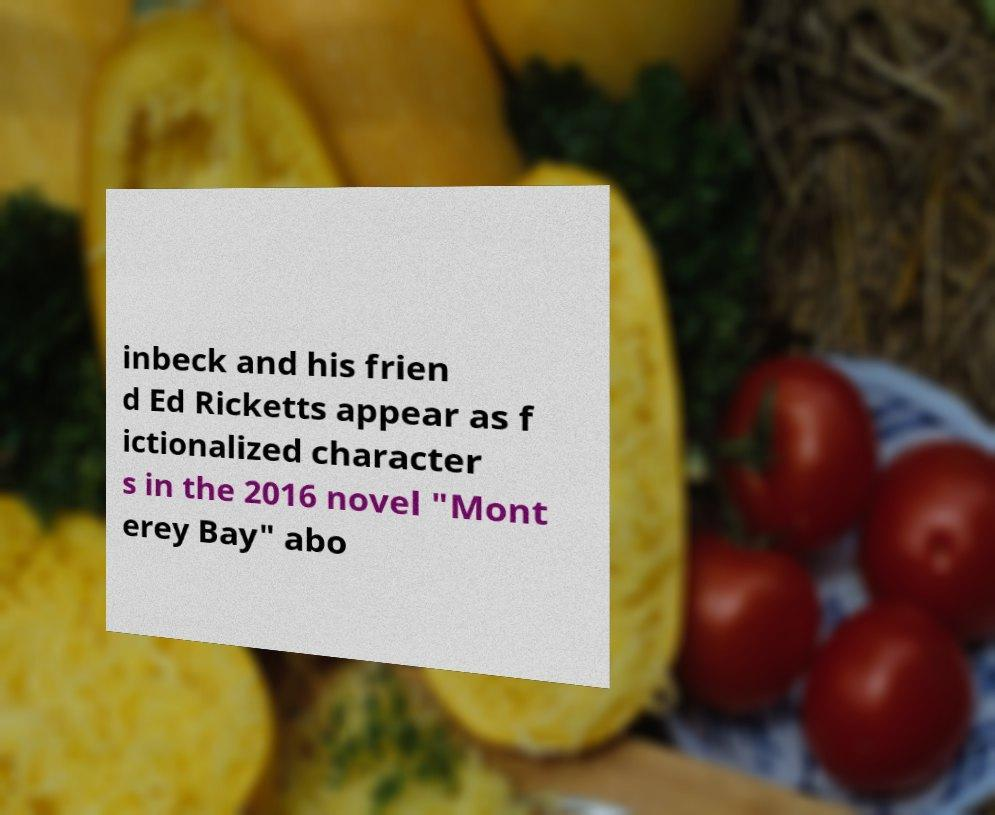Can you accurately transcribe the text from the provided image for me? inbeck and his frien d Ed Ricketts appear as f ictionalized character s in the 2016 novel "Mont erey Bay" abo 